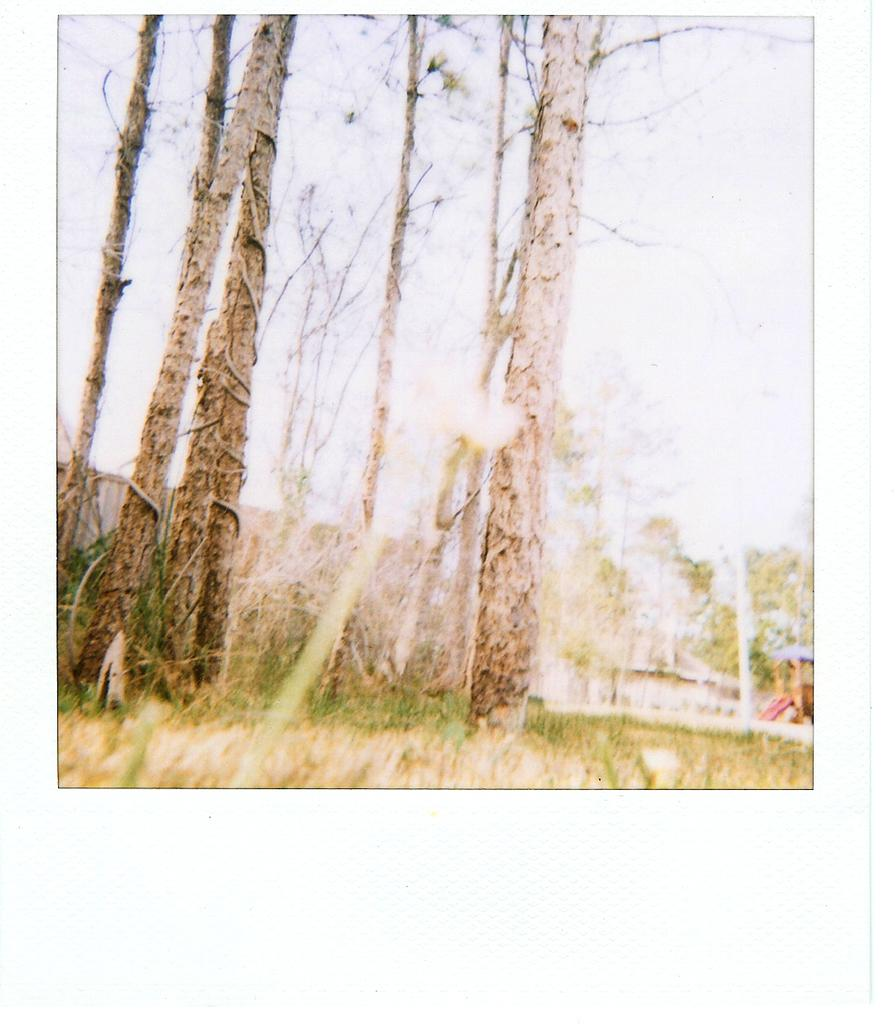What type of natural objects can be seen in the image? There are tree trunks in the image. What type of vegetation is visible in the image? There is grass visible in the image. What part of the natural environment is visible in the image? The sky is visible in the image. What type of behavior can be observed in the playground in the image? There is no playground present in the image, so it is not possible to observe any behavior. 